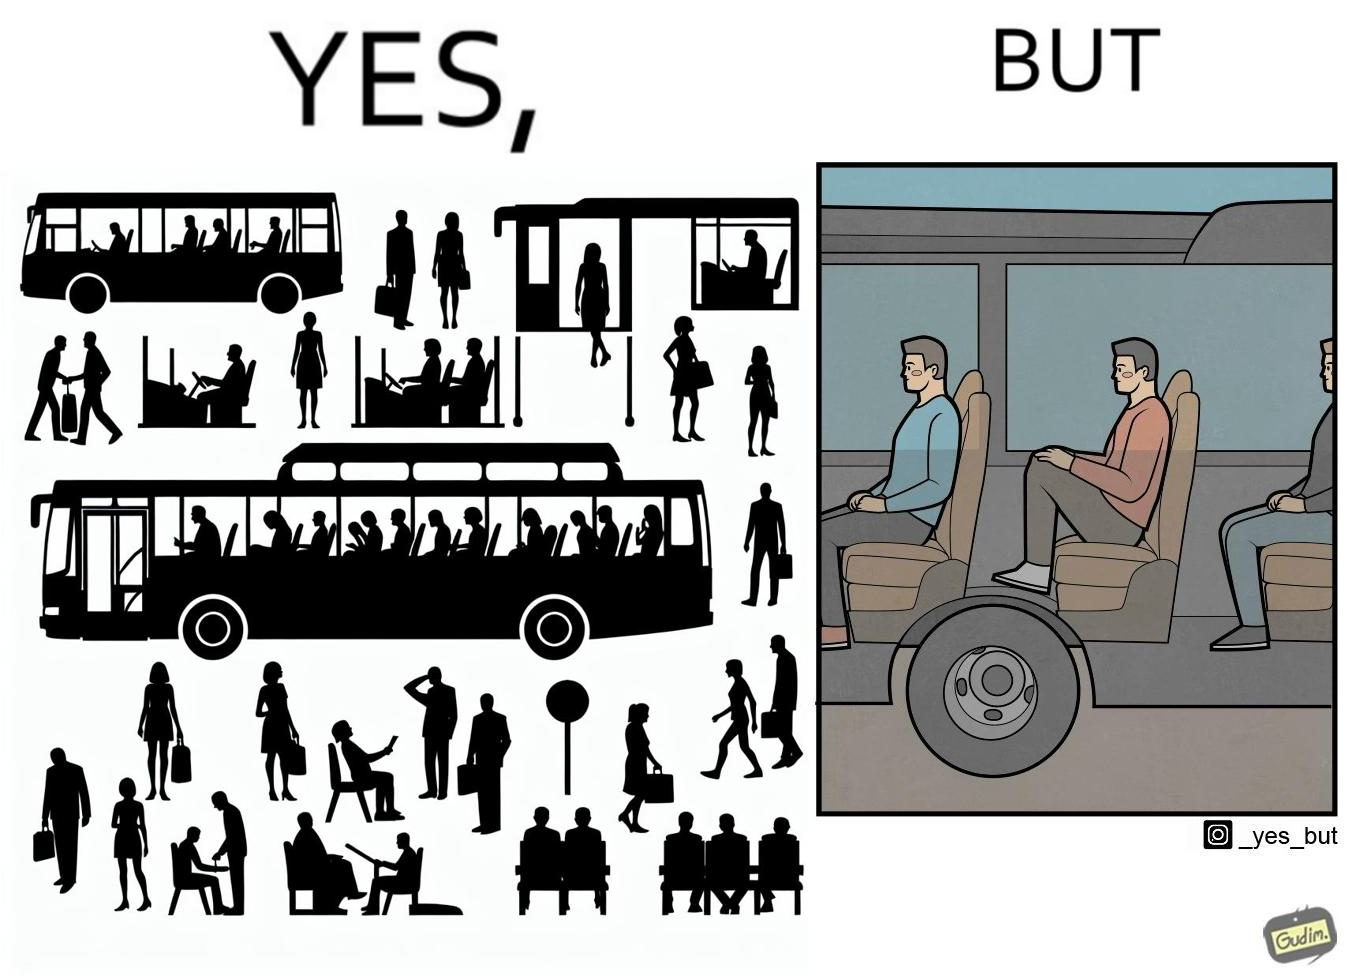Would you classify this image as satirical? Yes, this image is satirical. 